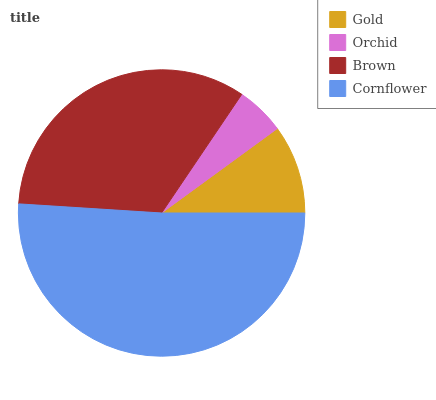Is Orchid the minimum?
Answer yes or no. Yes. Is Cornflower the maximum?
Answer yes or no. Yes. Is Brown the minimum?
Answer yes or no. No. Is Brown the maximum?
Answer yes or no. No. Is Brown greater than Orchid?
Answer yes or no. Yes. Is Orchid less than Brown?
Answer yes or no. Yes. Is Orchid greater than Brown?
Answer yes or no. No. Is Brown less than Orchid?
Answer yes or no. No. Is Brown the high median?
Answer yes or no. Yes. Is Gold the low median?
Answer yes or no. Yes. Is Cornflower the high median?
Answer yes or no. No. Is Cornflower the low median?
Answer yes or no. No. 